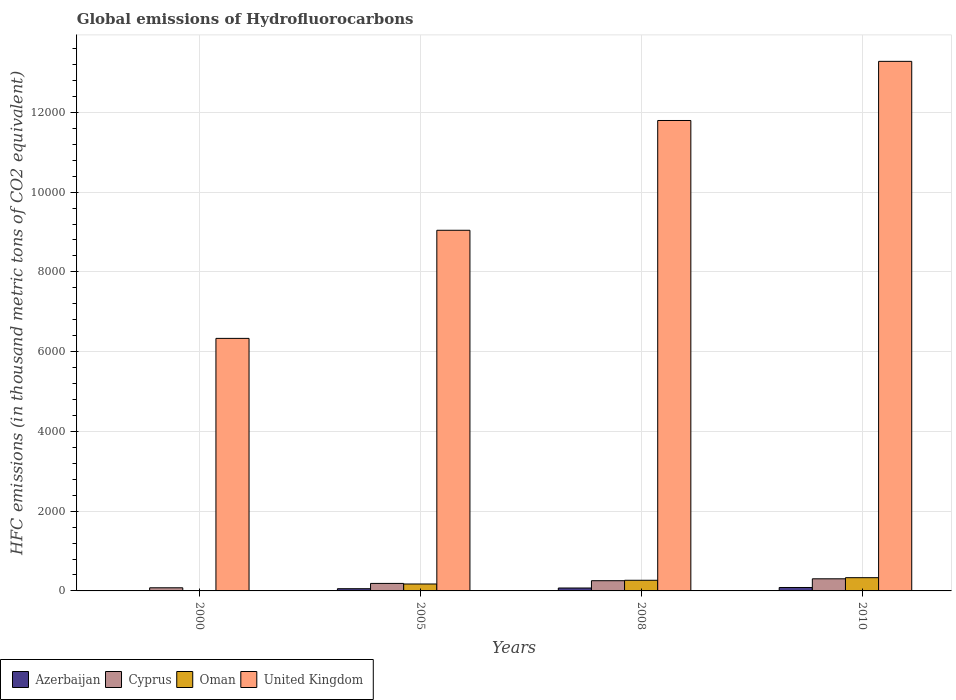How many groups of bars are there?
Keep it short and to the point. 4. Are the number of bars per tick equal to the number of legend labels?
Give a very brief answer. Yes. How many bars are there on the 3rd tick from the left?
Keep it short and to the point. 4. How many bars are there on the 3rd tick from the right?
Offer a very short reply. 4. What is the label of the 4th group of bars from the left?
Provide a short and direct response. 2010. In how many cases, is the number of bars for a given year not equal to the number of legend labels?
Your answer should be compact. 0. What is the global emissions of Hydrofluorocarbons in United Kingdom in 2010?
Offer a terse response. 1.33e+04. Across all years, what is the maximum global emissions of Hydrofluorocarbons in United Kingdom?
Ensure brevity in your answer.  1.33e+04. Across all years, what is the minimum global emissions of Hydrofluorocarbons in United Kingdom?
Give a very brief answer. 6332.5. In which year was the global emissions of Hydrofluorocarbons in Azerbaijan maximum?
Offer a terse response. 2010. What is the total global emissions of Hydrofluorocarbons in United Kingdom in the graph?
Provide a short and direct response. 4.05e+04. What is the difference between the global emissions of Hydrofluorocarbons in Cyprus in 2008 and that in 2010?
Ensure brevity in your answer.  -47.9. What is the difference between the global emissions of Hydrofluorocarbons in Cyprus in 2000 and the global emissions of Hydrofluorocarbons in Azerbaijan in 2005?
Provide a succinct answer. 23. What is the average global emissions of Hydrofluorocarbons in Azerbaijan per year?
Offer a very short reply. 55.75. In the year 2005, what is the difference between the global emissions of Hydrofluorocarbons in Azerbaijan and global emissions of Hydrofluorocarbons in Oman?
Provide a short and direct response. -118.2. What is the ratio of the global emissions of Hydrofluorocarbons in United Kingdom in 2000 to that in 2010?
Provide a succinct answer. 0.48. Is the difference between the global emissions of Hydrofluorocarbons in Azerbaijan in 2000 and 2005 greater than the difference between the global emissions of Hydrofluorocarbons in Oman in 2000 and 2005?
Your answer should be compact. Yes. What is the difference between the highest and the second highest global emissions of Hydrofluorocarbons in Oman?
Give a very brief answer. 65.1. What is the difference between the highest and the lowest global emissions of Hydrofluorocarbons in United Kingdom?
Give a very brief answer. 6946.5. In how many years, is the global emissions of Hydrofluorocarbons in Cyprus greater than the average global emissions of Hydrofluorocarbons in Cyprus taken over all years?
Keep it short and to the point. 2. Is the sum of the global emissions of Hydrofluorocarbons in Cyprus in 2000 and 2010 greater than the maximum global emissions of Hydrofluorocarbons in Oman across all years?
Keep it short and to the point. Yes. Is it the case that in every year, the sum of the global emissions of Hydrofluorocarbons in Azerbaijan and global emissions of Hydrofluorocarbons in Cyprus is greater than the sum of global emissions of Hydrofluorocarbons in United Kingdom and global emissions of Hydrofluorocarbons in Oman?
Your response must be concise. No. What does the 3rd bar from the left in 2005 represents?
Your answer should be very brief. Oman. What does the 3rd bar from the right in 2000 represents?
Your response must be concise. Cyprus. Is it the case that in every year, the sum of the global emissions of Hydrofluorocarbons in Oman and global emissions of Hydrofluorocarbons in Azerbaijan is greater than the global emissions of Hydrofluorocarbons in Cyprus?
Make the answer very short. No. What is the difference between two consecutive major ticks on the Y-axis?
Keep it short and to the point. 2000. Does the graph contain any zero values?
Offer a very short reply. No. How many legend labels are there?
Provide a succinct answer. 4. How are the legend labels stacked?
Give a very brief answer. Horizontal. What is the title of the graph?
Provide a short and direct response. Global emissions of Hydrofluorocarbons. Does "St. Kitts and Nevis" appear as one of the legend labels in the graph?
Give a very brief answer. No. What is the label or title of the Y-axis?
Keep it short and to the point. HFC emissions (in thousand metric tons of CO2 equivalent). What is the HFC emissions (in thousand metric tons of CO2 equivalent) of Azerbaijan in 2000?
Ensure brevity in your answer.  8.5. What is the HFC emissions (in thousand metric tons of CO2 equivalent) in Cyprus in 2000?
Ensure brevity in your answer.  78.4. What is the HFC emissions (in thousand metric tons of CO2 equivalent) of Oman in 2000?
Provide a short and direct response. 8.6. What is the HFC emissions (in thousand metric tons of CO2 equivalent) of United Kingdom in 2000?
Give a very brief answer. 6332.5. What is the HFC emissions (in thousand metric tons of CO2 equivalent) of Azerbaijan in 2005?
Keep it short and to the point. 55.4. What is the HFC emissions (in thousand metric tons of CO2 equivalent) of Cyprus in 2005?
Give a very brief answer. 188.3. What is the HFC emissions (in thousand metric tons of CO2 equivalent) in Oman in 2005?
Make the answer very short. 173.6. What is the HFC emissions (in thousand metric tons of CO2 equivalent) in United Kingdom in 2005?
Your answer should be very brief. 9043.4. What is the HFC emissions (in thousand metric tons of CO2 equivalent) of Azerbaijan in 2008?
Your response must be concise. 73.1. What is the HFC emissions (in thousand metric tons of CO2 equivalent) of Cyprus in 2008?
Keep it short and to the point. 256.1. What is the HFC emissions (in thousand metric tons of CO2 equivalent) of Oman in 2008?
Your answer should be compact. 266.9. What is the HFC emissions (in thousand metric tons of CO2 equivalent) in United Kingdom in 2008?
Make the answer very short. 1.18e+04. What is the HFC emissions (in thousand metric tons of CO2 equivalent) of Azerbaijan in 2010?
Your response must be concise. 86. What is the HFC emissions (in thousand metric tons of CO2 equivalent) of Cyprus in 2010?
Offer a terse response. 304. What is the HFC emissions (in thousand metric tons of CO2 equivalent) in Oman in 2010?
Provide a succinct answer. 332. What is the HFC emissions (in thousand metric tons of CO2 equivalent) of United Kingdom in 2010?
Your answer should be compact. 1.33e+04. Across all years, what is the maximum HFC emissions (in thousand metric tons of CO2 equivalent) of Azerbaijan?
Offer a very short reply. 86. Across all years, what is the maximum HFC emissions (in thousand metric tons of CO2 equivalent) in Cyprus?
Keep it short and to the point. 304. Across all years, what is the maximum HFC emissions (in thousand metric tons of CO2 equivalent) in Oman?
Your answer should be compact. 332. Across all years, what is the maximum HFC emissions (in thousand metric tons of CO2 equivalent) in United Kingdom?
Offer a terse response. 1.33e+04. Across all years, what is the minimum HFC emissions (in thousand metric tons of CO2 equivalent) in Azerbaijan?
Your response must be concise. 8.5. Across all years, what is the minimum HFC emissions (in thousand metric tons of CO2 equivalent) of Cyprus?
Your answer should be very brief. 78.4. Across all years, what is the minimum HFC emissions (in thousand metric tons of CO2 equivalent) of Oman?
Ensure brevity in your answer.  8.6. Across all years, what is the minimum HFC emissions (in thousand metric tons of CO2 equivalent) of United Kingdom?
Your answer should be very brief. 6332.5. What is the total HFC emissions (in thousand metric tons of CO2 equivalent) in Azerbaijan in the graph?
Make the answer very short. 223. What is the total HFC emissions (in thousand metric tons of CO2 equivalent) in Cyprus in the graph?
Ensure brevity in your answer.  826.8. What is the total HFC emissions (in thousand metric tons of CO2 equivalent) in Oman in the graph?
Your answer should be compact. 781.1. What is the total HFC emissions (in thousand metric tons of CO2 equivalent) of United Kingdom in the graph?
Your response must be concise. 4.05e+04. What is the difference between the HFC emissions (in thousand metric tons of CO2 equivalent) of Azerbaijan in 2000 and that in 2005?
Ensure brevity in your answer.  -46.9. What is the difference between the HFC emissions (in thousand metric tons of CO2 equivalent) of Cyprus in 2000 and that in 2005?
Make the answer very short. -109.9. What is the difference between the HFC emissions (in thousand metric tons of CO2 equivalent) in Oman in 2000 and that in 2005?
Your answer should be compact. -165. What is the difference between the HFC emissions (in thousand metric tons of CO2 equivalent) in United Kingdom in 2000 and that in 2005?
Keep it short and to the point. -2710.9. What is the difference between the HFC emissions (in thousand metric tons of CO2 equivalent) in Azerbaijan in 2000 and that in 2008?
Your answer should be compact. -64.6. What is the difference between the HFC emissions (in thousand metric tons of CO2 equivalent) of Cyprus in 2000 and that in 2008?
Keep it short and to the point. -177.7. What is the difference between the HFC emissions (in thousand metric tons of CO2 equivalent) of Oman in 2000 and that in 2008?
Keep it short and to the point. -258.3. What is the difference between the HFC emissions (in thousand metric tons of CO2 equivalent) of United Kingdom in 2000 and that in 2008?
Provide a succinct answer. -5463.5. What is the difference between the HFC emissions (in thousand metric tons of CO2 equivalent) of Azerbaijan in 2000 and that in 2010?
Provide a succinct answer. -77.5. What is the difference between the HFC emissions (in thousand metric tons of CO2 equivalent) of Cyprus in 2000 and that in 2010?
Ensure brevity in your answer.  -225.6. What is the difference between the HFC emissions (in thousand metric tons of CO2 equivalent) of Oman in 2000 and that in 2010?
Your answer should be compact. -323.4. What is the difference between the HFC emissions (in thousand metric tons of CO2 equivalent) of United Kingdom in 2000 and that in 2010?
Ensure brevity in your answer.  -6946.5. What is the difference between the HFC emissions (in thousand metric tons of CO2 equivalent) in Azerbaijan in 2005 and that in 2008?
Your answer should be compact. -17.7. What is the difference between the HFC emissions (in thousand metric tons of CO2 equivalent) of Cyprus in 2005 and that in 2008?
Your response must be concise. -67.8. What is the difference between the HFC emissions (in thousand metric tons of CO2 equivalent) in Oman in 2005 and that in 2008?
Offer a terse response. -93.3. What is the difference between the HFC emissions (in thousand metric tons of CO2 equivalent) in United Kingdom in 2005 and that in 2008?
Provide a short and direct response. -2752.6. What is the difference between the HFC emissions (in thousand metric tons of CO2 equivalent) of Azerbaijan in 2005 and that in 2010?
Ensure brevity in your answer.  -30.6. What is the difference between the HFC emissions (in thousand metric tons of CO2 equivalent) in Cyprus in 2005 and that in 2010?
Make the answer very short. -115.7. What is the difference between the HFC emissions (in thousand metric tons of CO2 equivalent) of Oman in 2005 and that in 2010?
Your response must be concise. -158.4. What is the difference between the HFC emissions (in thousand metric tons of CO2 equivalent) in United Kingdom in 2005 and that in 2010?
Ensure brevity in your answer.  -4235.6. What is the difference between the HFC emissions (in thousand metric tons of CO2 equivalent) of Azerbaijan in 2008 and that in 2010?
Keep it short and to the point. -12.9. What is the difference between the HFC emissions (in thousand metric tons of CO2 equivalent) of Cyprus in 2008 and that in 2010?
Make the answer very short. -47.9. What is the difference between the HFC emissions (in thousand metric tons of CO2 equivalent) of Oman in 2008 and that in 2010?
Keep it short and to the point. -65.1. What is the difference between the HFC emissions (in thousand metric tons of CO2 equivalent) in United Kingdom in 2008 and that in 2010?
Keep it short and to the point. -1483. What is the difference between the HFC emissions (in thousand metric tons of CO2 equivalent) of Azerbaijan in 2000 and the HFC emissions (in thousand metric tons of CO2 equivalent) of Cyprus in 2005?
Keep it short and to the point. -179.8. What is the difference between the HFC emissions (in thousand metric tons of CO2 equivalent) in Azerbaijan in 2000 and the HFC emissions (in thousand metric tons of CO2 equivalent) in Oman in 2005?
Make the answer very short. -165.1. What is the difference between the HFC emissions (in thousand metric tons of CO2 equivalent) of Azerbaijan in 2000 and the HFC emissions (in thousand metric tons of CO2 equivalent) of United Kingdom in 2005?
Keep it short and to the point. -9034.9. What is the difference between the HFC emissions (in thousand metric tons of CO2 equivalent) of Cyprus in 2000 and the HFC emissions (in thousand metric tons of CO2 equivalent) of Oman in 2005?
Offer a very short reply. -95.2. What is the difference between the HFC emissions (in thousand metric tons of CO2 equivalent) in Cyprus in 2000 and the HFC emissions (in thousand metric tons of CO2 equivalent) in United Kingdom in 2005?
Your response must be concise. -8965. What is the difference between the HFC emissions (in thousand metric tons of CO2 equivalent) of Oman in 2000 and the HFC emissions (in thousand metric tons of CO2 equivalent) of United Kingdom in 2005?
Provide a succinct answer. -9034.8. What is the difference between the HFC emissions (in thousand metric tons of CO2 equivalent) of Azerbaijan in 2000 and the HFC emissions (in thousand metric tons of CO2 equivalent) of Cyprus in 2008?
Keep it short and to the point. -247.6. What is the difference between the HFC emissions (in thousand metric tons of CO2 equivalent) in Azerbaijan in 2000 and the HFC emissions (in thousand metric tons of CO2 equivalent) in Oman in 2008?
Your response must be concise. -258.4. What is the difference between the HFC emissions (in thousand metric tons of CO2 equivalent) in Azerbaijan in 2000 and the HFC emissions (in thousand metric tons of CO2 equivalent) in United Kingdom in 2008?
Provide a succinct answer. -1.18e+04. What is the difference between the HFC emissions (in thousand metric tons of CO2 equivalent) in Cyprus in 2000 and the HFC emissions (in thousand metric tons of CO2 equivalent) in Oman in 2008?
Your response must be concise. -188.5. What is the difference between the HFC emissions (in thousand metric tons of CO2 equivalent) of Cyprus in 2000 and the HFC emissions (in thousand metric tons of CO2 equivalent) of United Kingdom in 2008?
Give a very brief answer. -1.17e+04. What is the difference between the HFC emissions (in thousand metric tons of CO2 equivalent) of Oman in 2000 and the HFC emissions (in thousand metric tons of CO2 equivalent) of United Kingdom in 2008?
Your response must be concise. -1.18e+04. What is the difference between the HFC emissions (in thousand metric tons of CO2 equivalent) of Azerbaijan in 2000 and the HFC emissions (in thousand metric tons of CO2 equivalent) of Cyprus in 2010?
Offer a terse response. -295.5. What is the difference between the HFC emissions (in thousand metric tons of CO2 equivalent) of Azerbaijan in 2000 and the HFC emissions (in thousand metric tons of CO2 equivalent) of Oman in 2010?
Provide a short and direct response. -323.5. What is the difference between the HFC emissions (in thousand metric tons of CO2 equivalent) in Azerbaijan in 2000 and the HFC emissions (in thousand metric tons of CO2 equivalent) in United Kingdom in 2010?
Your response must be concise. -1.33e+04. What is the difference between the HFC emissions (in thousand metric tons of CO2 equivalent) of Cyprus in 2000 and the HFC emissions (in thousand metric tons of CO2 equivalent) of Oman in 2010?
Your response must be concise. -253.6. What is the difference between the HFC emissions (in thousand metric tons of CO2 equivalent) of Cyprus in 2000 and the HFC emissions (in thousand metric tons of CO2 equivalent) of United Kingdom in 2010?
Provide a succinct answer. -1.32e+04. What is the difference between the HFC emissions (in thousand metric tons of CO2 equivalent) of Oman in 2000 and the HFC emissions (in thousand metric tons of CO2 equivalent) of United Kingdom in 2010?
Your response must be concise. -1.33e+04. What is the difference between the HFC emissions (in thousand metric tons of CO2 equivalent) of Azerbaijan in 2005 and the HFC emissions (in thousand metric tons of CO2 equivalent) of Cyprus in 2008?
Offer a very short reply. -200.7. What is the difference between the HFC emissions (in thousand metric tons of CO2 equivalent) in Azerbaijan in 2005 and the HFC emissions (in thousand metric tons of CO2 equivalent) in Oman in 2008?
Your answer should be compact. -211.5. What is the difference between the HFC emissions (in thousand metric tons of CO2 equivalent) of Azerbaijan in 2005 and the HFC emissions (in thousand metric tons of CO2 equivalent) of United Kingdom in 2008?
Provide a succinct answer. -1.17e+04. What is the difference between the HFC emissions (in thousand metric tons of CO2 equivalent) in Cyprus in 2005 and the HFC emissions (in thousand metric tons of CO2 equivalent) in Oman in 2008?
Offer a very short reply. -78.6. What is the difference between the HFC emissions (in thousand metric tons of CO2 equivalent) in Cyprus in 2005 and the HFC emissions (in thousand metric tons of CO2 equivalent) in United Kingdom in 2008?
Offer a terse response. -1.16e+04. What is the difference between the HFC emissions (in thousand metric tons of CO2 equivalent) of Oman in 2005 and the HFC emissions (in thousand metric tons of CO2 equivalent) of United Kingdom in 2008?
Offer a very short reply. -1.16e+04. What is the difference between the HFC emissions (in thousand metric tons of CO2 equivalent) in Azerbaijan in 2005 and the HFC emissions (in thousand metric tons of CO2 equivalent) in Cyprus in 2010?
Keep it short and to the point. -248.6. What is the difference between the HFC emissions (in thousand metric tons of CO2 equivalent) of Azerbaijan in 2005 and the HFC emissions (in thousand metric tons of CO2 equivalent) of Oman in 2010?
Make the answer very short. -276.6. What is the difference between the HFC emissions (in thousand metric tons of CO2 equivalent) in Azerbaijan in 2005 and the HFC emissions (in thousand metric tons of CO2 equivalent) in United Kingdom in 2010?
Offer a very short reply. -1.32e+04. What is the difference between the HFC emissions (in thousand metric tons of CO2 equivalent) in Cyprus in 2005 and the HFC emissions (in thousand metric tons of CO2 equivalent) in Oman in 2010?
Provide a succinct answer. -143.7. What is the difference between the HFC emissions (in thousand metric tons of CO2 equivalent) in Cyprus in 2005 and the HFC emissions (in thousand metric tons of CO2 equivalent) in United Kingdom in 2010?
Keep it short and to the point. -1.31e+04. What is the difference between the HFC emissions (in thousand metric tons of CO2 equivalent) of Oman in 2005 and the HFC emissions (in thousand metric tons of CO2 equivalent) of United Kingdom in 2010?
Give a very brief answer. -1.31e+04. What is the difference between the HFC emissions (in thousand metric tons of CO2 equivalent) in Azerbaijan in 2008 and the HFC emissions (in thousand metric tons of CO2 equivalent) in Cyprus in 2010?
Keep it short and to the point. -230.9. What is the difference between the HFC emissions (in thousand metric tons of CO2 equivalent) of Azerbaijan in 2008 and the HFC emissions (in thousand metric tons of CO2 equivalent) of Oman in 2010?
Ensure brevity in your answer.  -258.9. What is the difference between the HFC emissions (in thousand metric tons of CO2 equivalent) in Azerbaijan in 2008 and the HFC emissions (in thousand metric tons of CO2 equivalent) in United Kingdom in 2010?
Provide a short and direct response. -1.32e+04. What is the difference between the HFC emissions (in thousand metric tons of CO2 equivalent) of Cyprus in 2008 and the HFC emissions (in thousand metric tons of CO2 equivalent) of Oman in 2010?
Offer a terse response. -75.9. What is the difference between the HFC emissions (in thousand metric tons of CO2 equivalent) in Cyprus in 2008 and the HFC emissions (in thousand metric tons of CO2 equivalent) in United Kingdom in 2010?
Your answer should be compact. -1.30e+04. What is the difference between the HFC emissions (in thousand metric tons of CO2 equivalent) of Oman in 2008 and the HFC emissions (in thousand metric tons of CO2 equivalent) of United Kingdom in 2010?
Provide a short and direct response. -1.30e+04. What is the average HFC emissions (in thousand metric tons of CO2 equivalent) in Azerbaijan per year?
Offer a terse response. 55.75. What is the average HFC emissions (in thousand metric tons of CO2 equivalent) in Cyprus per year?
Provide a short and direct response. 206.7. What is the average HFC emissions (in thousand metric tons of CO2 equivalent) of Oman per year?
Provide a short and direct response. 195.28. What is the average HFC emissions (in thousand metric tons of CO2 equivalent) of United Kingdom per year?
Your answer should be very brief. 1.01e+04. In the year 2000, what is the difference between the HFC emissions (in thousand metric tons of CO2 equivalent) of Azerbaijan and HFC emissions (in thousand metric tons of CO2 equivalent) of Cyprus?
Keep it short and to the point. -69.9. In the year 2000, what is the difference between the HFC emissions (in thousand metric tons of CO2 equivalent) of Azerbaijan and HFC emissions (in thousand metric tons of CO2 equivalent) of Oman?
Your answer should be compact. -0.1. In the year 2000, what is the difference between the HFC emissions (in thousand metric tons of CO2 equivalent) of Azerbaijan and HFC emissions (in thousand metric tons of CO2 equivalent) of United Kingdom?
Ensure brevity in your answer.  -6324. In the year 2000, what is the difference between the HFC emissions (in thousand metric tons of CO2 equivalent) of Cyprus and HFC emissions (in thousand metric tons of CO2 equivalent) of Oman?
Offer a very short reply. 69.8. In the year 2000, what is the difference between the HFC emissions (in thousand metric tons of CO2 equivalent) in Cyprus and HFC emissions (in thousand metric tons of CO2 equivalent) in United Kingdom?
Keep it short and to the point. -6254.1. In the year 2000, what is the difference between the HFC emissions (in thousand metric tons of CO2 equivalent) of Oman and HFC emissions (in thousand metric tons of CO2 equivalent) of United Kingdom?
Give a very brief answer. -6323.9. In the year 2005, what is the difference between the HFC emissions (in thousand metric tons of CO2 equivalent) of Azerbaijan and HFC emissions (in thousand metric tons of CO2 equivalent) of Cyprus?
Make the answer very short. -132.9. In the year 2005, what is the difference between the HFC emissions (in thousand metric tons of CO2 equivalent) of Azerbaijan and HFC emissions (in thousand metric tons of CO2 equivalent) of Oman?
Offer a terse response. -118.2. In the year 2005, what is the difference between the HFC emissions (in thousand metric tons of CO2 equivalent) in Azerbaijan and HFC emissions (in thousand metric tons of CO2 equivalent) in United Kingdom?
Your response must be concise. -8988. In the year 2005, what is the difference between the HFC emissions (in thousand metric tons of CO2 equivalent) of Cyprus and HFC emissions (in thousand metric tons of CO2 equivalent) of United Kingdom?
Ensure brevity in your answer.  -8855.1. In the year 2005, what is the difference between the HFC emissions (in thousand metric tons of CO2 equivalent) of Oman and HFC emissions (in thousand metric tons of CO2 equivalent) of United Kingdom?
Your answer should be compact. -8869.8. In the year 2008, what is the difference between the HFC emissions (in thousand metric tons of CO2 equivalent) in Azerbaijan and HFC emissions (in thousand metric tons of CO2 equivalent) in Cyprus?
Give a very brief answer. -183. In the year 2008, what is the difference between the HFC emissions (in thousand metric tons of CO2 equivalent) in Azerbaijan and HFC emissions (in thousand metric tons of CO2 equivalent) in Oman?
Provide a short and direct response. -193.8. In the year 2008, what is the difference between the HFC emissions (in thousand metric tons of CO2 equivalent) of Azerbaijan and HFC emissions (in thousand metric tons of CO2 equivalent) of United Kingdom?
Ensure brevity in your answer.  -1.17e+04. In the year 2008, what is the difference between the HFC emissions (in thousand metric tons of CO2 equivalent) of Cyprus and HFC emissions (in thousand metric tons of CO2 equivalent) of Oman?
Give a very brief answer. -10.8. In the year 2008, what is the difference between the HFC emissions (in thousand metric tons of CO2 equivalent) in Cyprus and HFC emissions (in thousand metric tons of CO2 equivalent) in United Kingdom?
Provide a succinct answer. -1.15e+04. In the year 2008, what is the difference between the HFC emissions (in thousand metric tons of CO2 equivalent) of Oman and HFC emissions (in thousand metric tons of CO2 equivalent) of United Kingdom?
Ensure brevity in your answer.  -1.15e+04. In the year 2010, what is the difference between the HFC emissions (in thousand metric tons of CO2 equivalent) of Azerbaijan and HFC emissions (in thousand metric tons of CO2 equivalent) of Cyprus?
Keep it short and to the point. -218. In the year 2010, what is the difference between the HFC emissions (in thousand metric tons of CO2 equivalent) of Azerbaijan and HFC emissions (in thousand metric tons of CO2 equivalent) of Oman?
Your answer should be very brief. -246. In the year 2010, what is the difference between the HFC emissions (in thousand metric tons of CO2 equivalent) of Azerbaijan and HFC emissions (in thousand metric tons of CO2 equivalent) of United Kingdom?
Offer a terse response. -1.32e+04. In the year 2010, what is the difference between the HFC emissions (in thousand metric tons of CO2 equivalent) in Cyprus and HFC emissions (in thousand metric tons of CO2 equivalent) in United Kingdom?
Give a very brief answer. -1.30e+04. In the year 2010, what is the difference between the HFC emissions (in thousand metric tons of CO2 equivalent) in Oman and HFC emissions (in thousand metric tons of CO2 equivalent) in United Kingdom?
Your answer should be compact. -1.29e+04. What is the ratio of the HFC emissions (in thousand metric tons of CO2 equivalent) of Azerbaijan in 2000 to that in 2005?
Ensure brevity in your answer.  0.15. What is the ratio of the HFC emissions (in thousand metric tons of CO2 equivalent) in Cyprus in 2000 to that in 2005?
Offer a terse response. 0.42. What is the ratio of the HFC emissions (in thousand metric tons of CO2 equivalent) of Oman in 2000 to that in 2005?
Provide a succinct answer. 0.05. What is the ratio of the HFC emissions (in thousand metric tons of CO2 equivalent) of United Kingdom in 2000 to that in 2005?
Offer a terse response. 0.7. What is the ratio of the HFC emissions (in thousand metric tons of CO2 equivalent) in Azerbaijan in 2000 to that in 2008?
Ensure brevity in your answer.  0.12. What is the ratio of the HFC emissions (in thousand metric tons of CO2 equivalent) in Cyprus in 2000 to that in 2008?
Provide a succinct answer. 0.31. What is the ratio of the HFC emissions (in thousand metric tons of CO2 equivalent) of Oman in 2000 to that in 2008?
Your response must be concise. 0.03. What is the ratio of the HFC emissions (in thousand metric tons of CO2 equivalent) in United Kingdom in 2000 to that in 2008?
Ensure brevity in your answer.  0.54. What is the ratio of the HFC emissions (in thousand metric tons of CO2 equivalent) of Azerbaijan in 2000 to that in 2010?
Your answer should be very brief. 0.1. What is the ratio of the HFC emissions (in thousand metric tons of CO2 equivalent) in Cyprus in 2000 to that in 2010?
Make the answer very short. 0.26. What is the ratio of the HFC emissions (in thousand metric tons of CO2 equivalent) of Oman in 2000 to that in 2010?
Make the answer very short. 0.03. What is the ratio of the HFC emissions (in thousand metric tons of CO2 equivalent) in United Kingdom in 2000 to that in 2010?
Ensure brevity in your answer.  0.48. What is the ratio of the HFC emissions (in thousand metric tons of CO2 equivalent) in Azerbaijan in 2005 to that in 2008?
Ensure brevity in your answer.  0.76. What is the ratio of the HFC emissions (in thousand metric tons of CO2 equivalent) in Cyprus in 2005 to that in 2008?
Keep it short and to the point. 0.74. What is the ratio of the HFC emissions (in thousand metric tons of CO2 equivalent) in Oman in 2005 to that in 2008?
Ensure brevity in your answer.  0.65. What is the ratio of the HFC emissions (in thousand metric tons of CO2 equivalent) of United Kingdom in 2005 to that in 2008?
Offer a very short reply. 0.77. What is the ratio of the HFC emissions (in thousand metric tons of CO2 equivalent) of Azerbaijan in 2005 to that in 2010?
Your answer should be compact. 0.64. What is the ratio of the HFC emissions (in thousand metric tons of CO2 equivalent) of Cyprus in 2005 to that in 2010?
Make the answer very short. 0.62. What is the ratio of the HFC emissions (in thousand metric tons of CO2 equivalent) of Oman in 2005 to that in 2010?
Give a very brief answer. 0.52. What is the ratio of the HFC emissions (in thousand metric tons of CO2 equivalent) of United Kingdom in 2005 to that in 2010?
Ensure brevity in your answer.  0.68. What is the ratio of the HFC emissions (in thousand metric tons of CO2 equivalent) of Cyprus in 2008 to that in 2010?
Your answer should be compact. 0.84. What is the ratio of the HFC emissions (in thousand metric tons of CO2 equivalent) of Oman in 2008 to that in 2010?
Offer a terse response. 0.8. What is the ratio of the HFC emissions (in thousand metric tons of CO2 equivalent) of United Kingdom in 2008 to that in 2010?
Offer a terse response. 0.89. What is the difference between the highest and the second highest HFC emissions (in thousand metric tons of CO2 equivalent) in Cyprus?
Your response must be concise. 47.9. What is the difference between the highest and the second highest HFC emissions (in thousand metric tons of CO2 equivalent) in Oman?
Your response must be concise. 65.1. What is the difference between the highest and the second highest HFC emissions (in thousand metric tons of CO2 equivalent) of United Kingdom?
Offer a very short reply. 1483. What is the difference between the highest and the lowest HFC emissions (in thousand metric tons of CO2 equivalent) in Azerbaijan?
Ensure brevity in your answer.  77.5. What is the difference between the highest and the lowest HFC emissions (in thousand metric tons of CO2 equivalent) of Cyprus?
Keep it short and to the point. 225.6. What is the difference between the highest and the lowest HFC emissions (in thousand metric tons of CO2 equivalent) in Oman?
Offer a terse response. 323.4. What is the difference between the highest and the lowest HFC emissions (in thousand metric tons of CO2 equivalent) of United Kingdom?
Keep it short and to the point. 6946.5. 